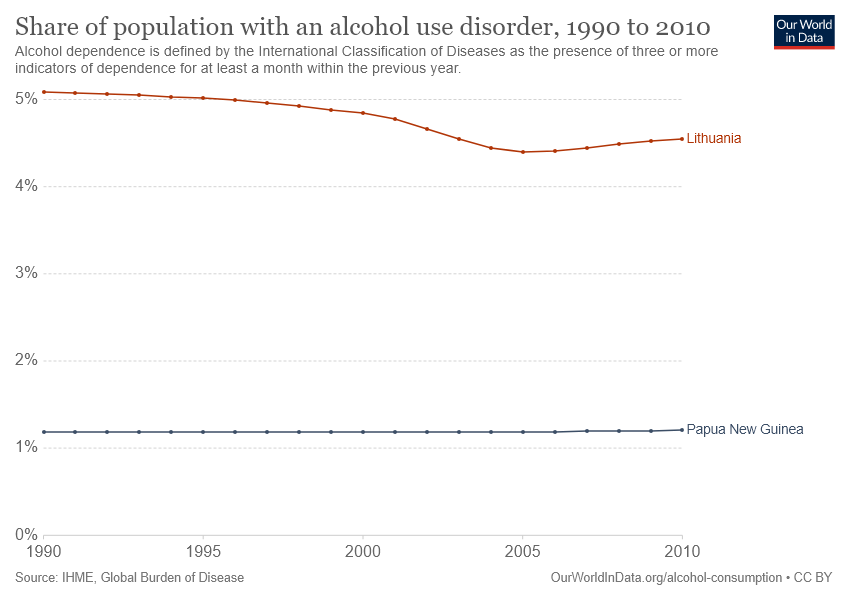Point out several critical features in this image. In 2014, less than 5% of the population in Lithuania had an alcohol use disorder. Lithuania and Papua New Guinea are the countries being compared in the given line graph. 